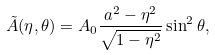<formula> <loc_0><loc_0><loc_500><loc_500>\tilde { A } ( \eta , \theta ) = A _ { 0 } \frac { a ^ { 2 } - \eta ^ { 2 } } { \sqrt { 1 - \eta ^ { 2 } } } \sin ^ { 2 } \theta ,</formula> 